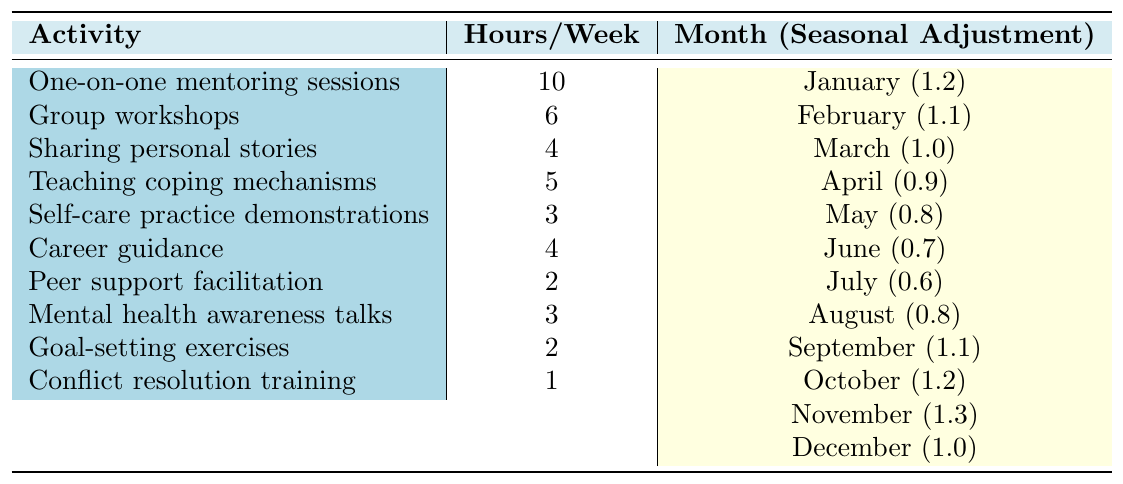What activity has the highest hours allocated per week? The table displays the hours allocated to each activity. Upon reviewing the values, "One-on-one mentoring sessions" shows the highest allocation with 10 hours per week.
Answer: One-on-one mentoring sessions What is the total number of hours allocated for "Sharing personal stories" and "Self-care practice demonstrations"? To find the total, add the hours for both activities: Sharing personal stories has 4 hours, and Self-care practice demonstrations have 3 hours. Thus, 4 + 3 = 7 hours in total.
Answer: 7 hours Is there any activity that has exactly 2 hours allocated per week? Reviewing the table, "Peer support facilitation" and "Goal-setting exercises" both have exactly 2 hours allocated per week. Therefore, the statement is true.
Answer: Yes What is the seasonal adjustment factor for "Teaching coping mechanisms"? The seasonal adjustment factor for "Teaching coping mechanisms" is provided in the table as 0.9.
Answer: 0.9 What is the average weekly hour allocation across all activities? First, sum up the hours allocated for all activities: 10 + 6 + 4 + 5 + 3 + 4 + 2 + 3 + 2 + 1 = 40. Then divide by the number of activities (10), resulting in an average of 40 / 10 = 4 hours per week.
Answer: 4 hours Which month has the highest seasonal adjustment factor, and what is that factor? Reviewing the seasonal adjustment factors for each month, December shows the highest factor at 1.3.
Answer: December, 1.3 What is the difference in hours allocated per week between the highest and lowest activity? The highest activity is "One-on-one mentoring sessions" with 10 hours, and the lowest is "Conflict resolution training" with 1 hour. The difference is 10 - 1 = 9 hours.
Answer: 9 hours During which month does "Mental health awareness talks" occur, and how many hours are allocated? According to the table, "Mental health awareness talks" occurs in August, and it has 3 hours allocated each week.
Answer: August, 3 hours How many activities have a total of 4 hours allocated weekly? From the table, two activities, "Sharing personal stories" and "Career guidance," each have 4 hours allocated weekly. Thus, there are 2 such activities.
Answer: 2 activities If one were to add up the hours allocated to the first five activities, what would the total be? The first five activities have the following hours: 10 + 6 + 4 + 5 + 3 = 28. Thus, the total is 28 hours.
Answer: 28 hours 